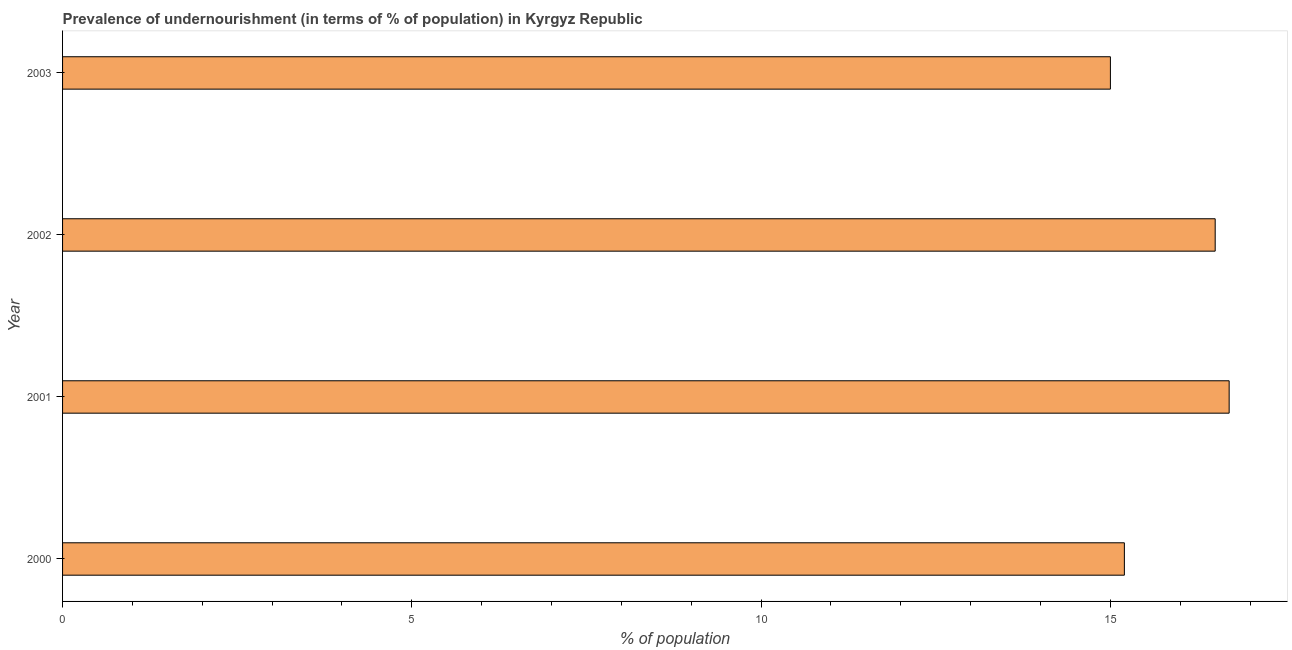Does the graph contain any zero values?
Your response must be concise. No. Does the graph contain grids?
Give a very brief answer. No. What is the title of the graph?
Give a very brief answer. Prevalence of undernourishment (in terms of % of population) in Kyrgyz Republic. What is the label or title of the X-axis?
Your response must be concise. % of population. What is the label or title of the Y-axis?
Provide a short and direct response. Year. What is the percentage of undernourished population in 2001?
Keep it short and to the point. 16.7. Across all years, what is the maximum percentage of undernourished population?
Keep it short and to the point. 16.7. Across all years, what is the minimum percentage of undernourished population?
Your answer should be compact. 15. In which year was the percentage of undernourished population maximum?
Offer a very short reply. 2001. In which year was the percentage of undernourished population minimum?
Your answer should be compact. 2003. What is the sum of the percentage of undernourished population?
Ensure brevity in your answer.  63.4. What is the difference between the percentage of undernourished population in 2002 and 2003?
Ensure brevity in your answer.  1.5. What is the average percentage of undernourished population per year?
Make the answer very short. 15.85. What is the median percentage of undernourished population?
Ensure brevity in your answer.  15.85. Do a majority of the years between 2002 and 2003 (inclusive) have percentage of undernourished population greater than 15 %?
Give a very brief answer. No. What is the ratio of the percentage of undernourished population in 2002 to that in 2003?
Ensure brevity in your answer.  1.1. Is the percentage of undernourished population in 2002 less than that in 2003?
Keep it short and to the point. No. Is the difference between the percentage of undernourished population in 2002 and 2003 greater than the difference between any two years?
Ensure brevity in your answer.  No. What is the difference between the highest and the second highest percentage of undernourished population?
Offer a terse response. 0.2. Is the sum of the percentage of undernourished population in 2000 and 2002 greater than the maximum percentage of undernourished population across all years?
Provide a short and direct response. Yes. What is the difference between the highest and the lowest percentage of undernourished population?
Provide a short and direct response. 1.7. How many years are there in the graph?
Offer a very short reply. 4. What is the difference between two consecutive major ticks on the X-axis?
Offer a terse response. 5. What is the % of population in 2000?
Offer a very short reply. 15.2. What is the % of population of 2001?
Keep it short and to the point. 16.7. What is the difference between the % of population in 2000 and 2003?
Provide a short and direct response. 0.2. What is the difference between the % of population in 2001 and 2003?
Your answer should be compact. 1.7. What is the difference between the % of population in 2002 and 2003?
Your answer should be compact. 1.5. What is the ratio of the % of population in 2000 to that in 2001?
Make the answer very short. 0.91. What is the ratio of the % of population in 2000 to that in 2002?
Your answer should be compact. 0.92. What is the ratio of the % of population in 2001 to that in 2003?
Offer a very short reply. 1.11. What is the ratio of the % of population in 2002 to that in 2003?
Your answer should be compact. 1.1. 